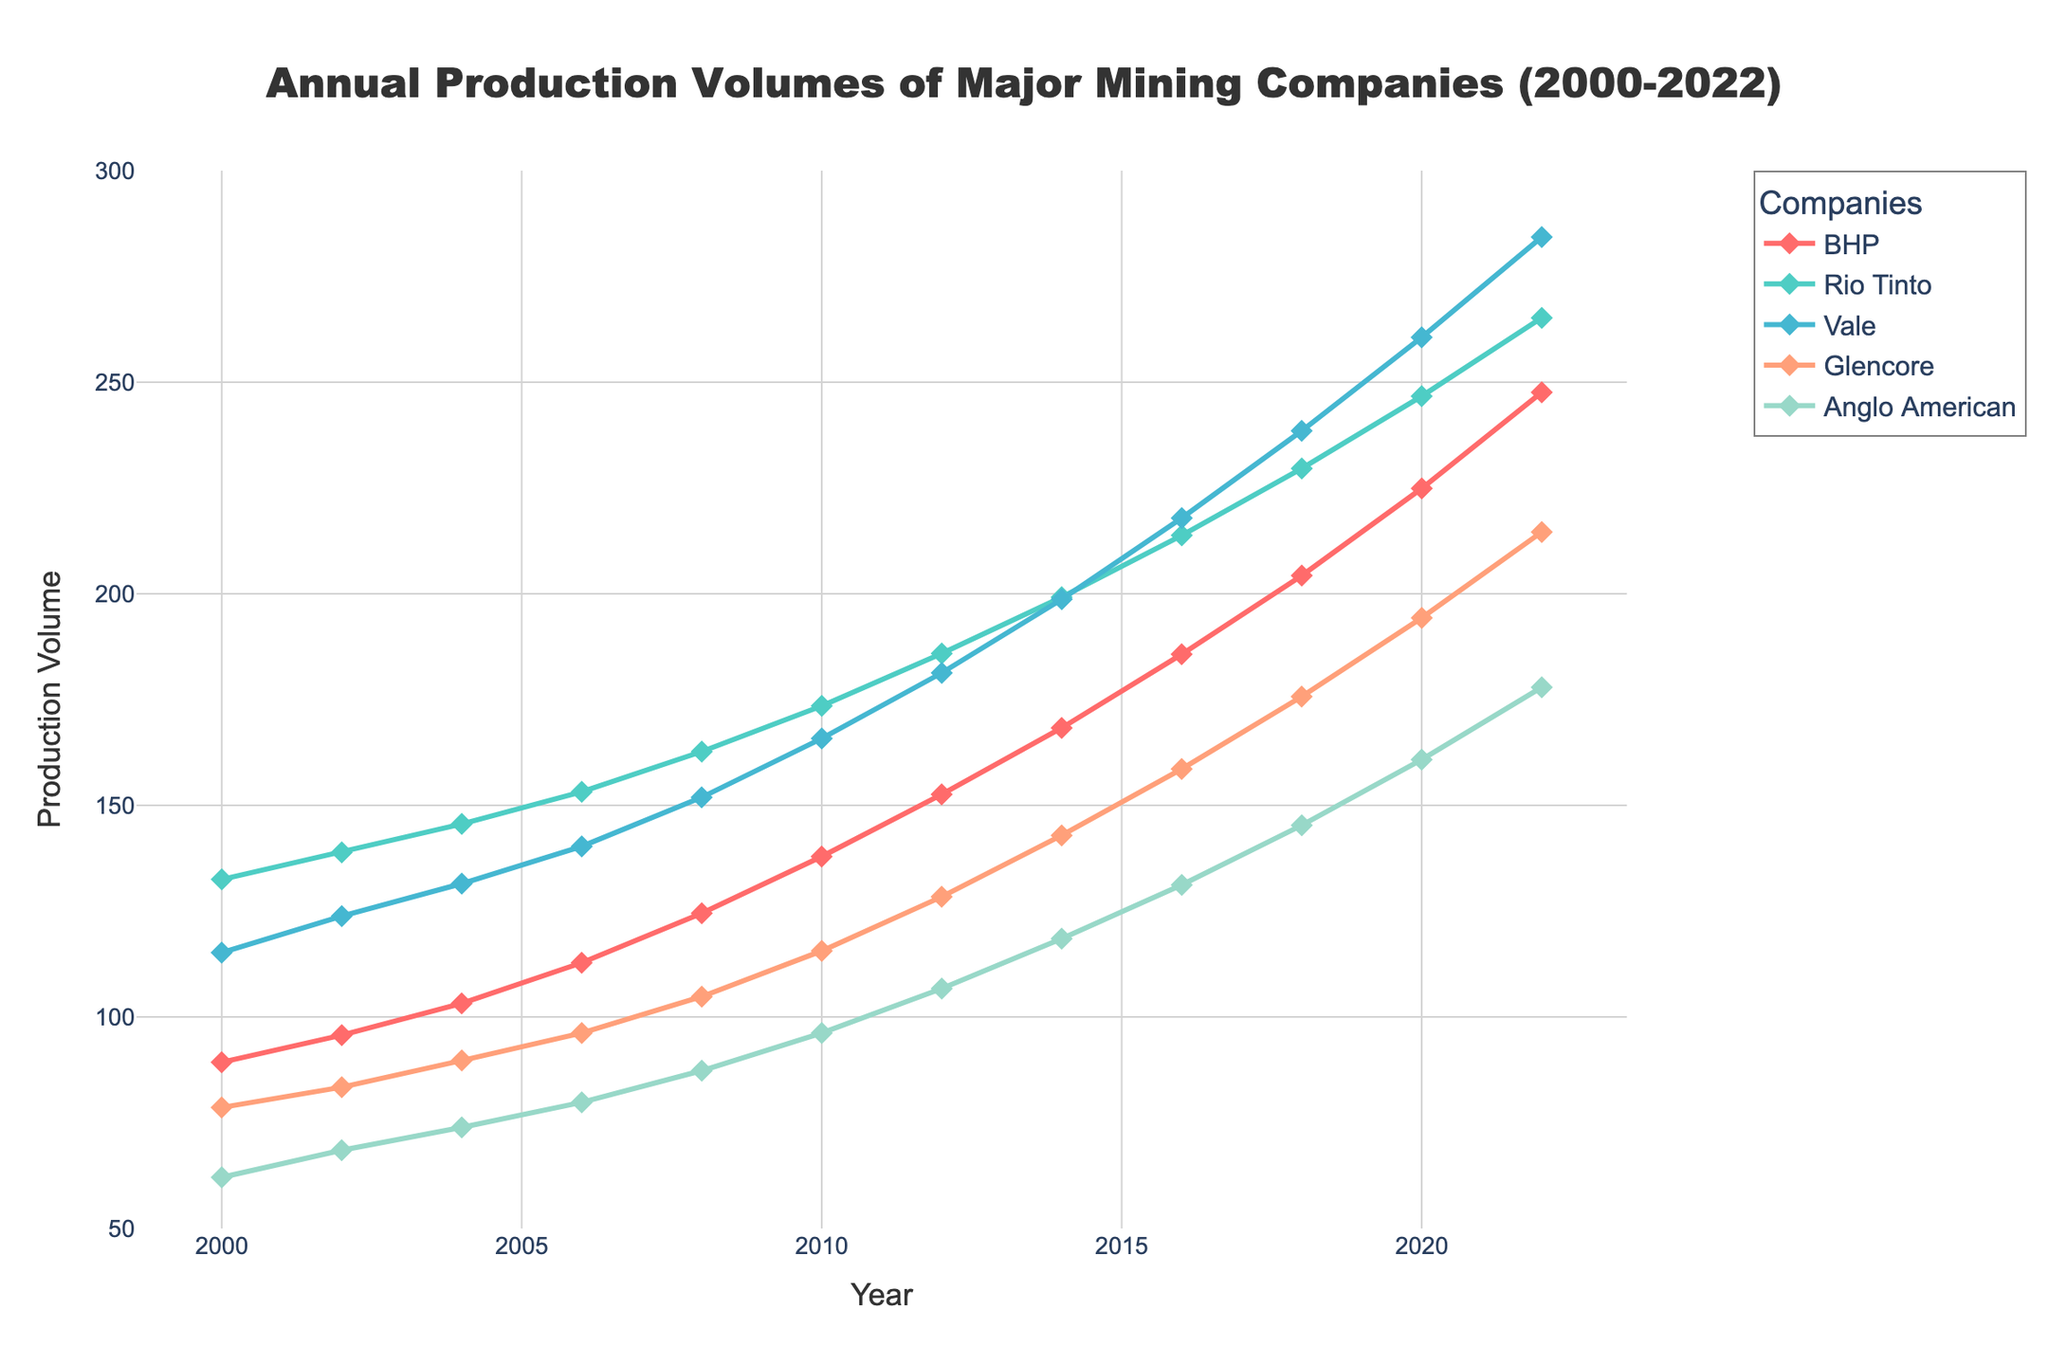What is the highest production volume for BHP in the given time period? To find the highest production volume for BHP, check the Y-axis values for the red line representing BHP. The highest value is at the year 2022, with 247.6.
Answer: 247.6 Which company had the lowest production volume in 2008 and what was it? By observing the 2008 data points on the X-axis and noting the heights of the lines or markers, it can be seen that Anglo American (purple line) had the lowest production volume in 2008, which was 87.3.
Answer: Anglo American, 87.3 Between 2010 and 2012, which company showed the greatest increase in production volume? Identify the differences between 2010 and 2012 data points for all companies. Calculation: BHP (152.6-137.9=14.7), Rio Tinto (185.9-173.5=12.4), Vale (181.3-165.8=15.5), Glencore (128.4-115.6=12.8), Anglo American (106.7-96.2=10.5). Vale showed the greatest increase of 15.5.
Answer: Vale How many companies had a production volume greater than 200 in 2020? Observe the 2020 data points and count the companies with values exceeding 200. They are BHP, Rio Tinto, and Vale. So, three companies.
Answer: 3 What was the average production volume of Anglo American between 2000 and 2022? Sum the production volumes of Anglo American from 2000 to 2022 and divide by the number of data points: (62.1 + 68.5 + 73.9 + 79.8 + 87.3 + 96.2 + 106.7 + 118.5 + 131.2 + 145.3 + 160.8 + 177.9) / 12 = 104.7 (Rounded value)
Answer: 104.7 Did any company experience a decrease in production volume between any two successive years? By comparing each company's production volume data year by year, it can be observed that no company had a decrease in production volume between successive years.
Answer: No Which company had the greatest production volume in 2016, and how much was it? Locate the 2016 data points and identify the company with the highest value. It is Vale with 217.9.
Answer: Vale, 217.9 In which year did Rio Tinto surpass the 200 mark in production volume, and what was the exact figure that year? Observe where the teal line (Rio Tinto) crosses the 200 production volume. It happens in 2016 with a value of 213.8.
Answer: 2016, 213.8 What is the total increase in production volume for Glencore between 2000 and 2022? Subtract Glencore's 2000 production volume from its 2022 production volume: 214.6 - 78.6 = 136
Answer: 136 What is the percentage increase in production volume for BHP from 2000 to 2022? Calculate the percentage increase: ((247.6 - 89.3) / 89.3) * 100 ≈ 177.3%
Answer: 177.3% 